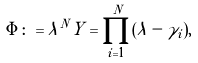Convert formula to latex. <formula><loc_0><loc_0><loc_500><loc_500>\Phi \colon = \lambda ^ { N } Y = \prod _ { i = 1 } ^ { N } ( \lambda - \gamma _ { i } ) ,</formula> 